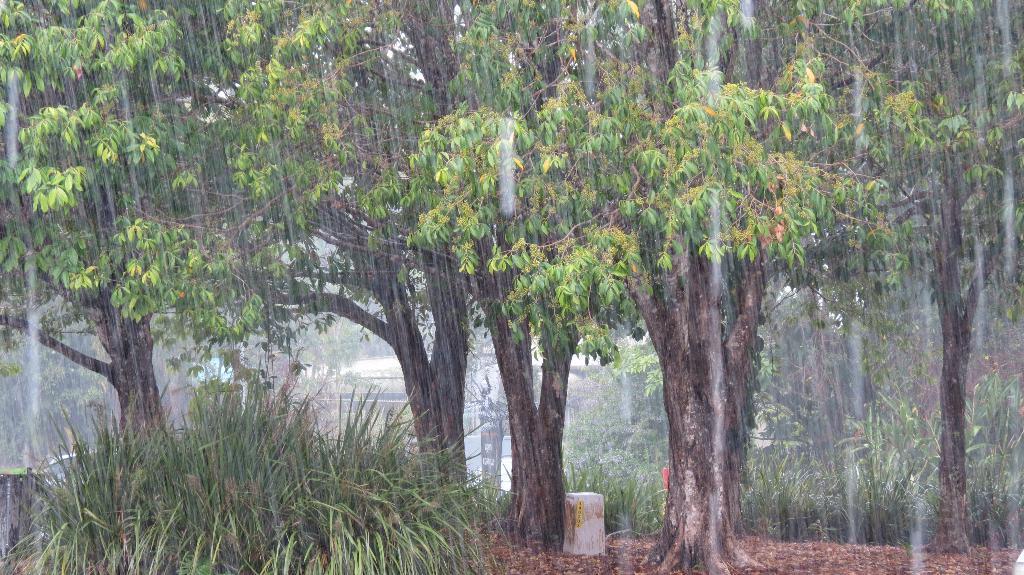Please provide a concise description of this image. This picture is clicked outside. In the foreground we can see the grass and in the background we can see the sky and the rain and we can see the green grass and some other items. 